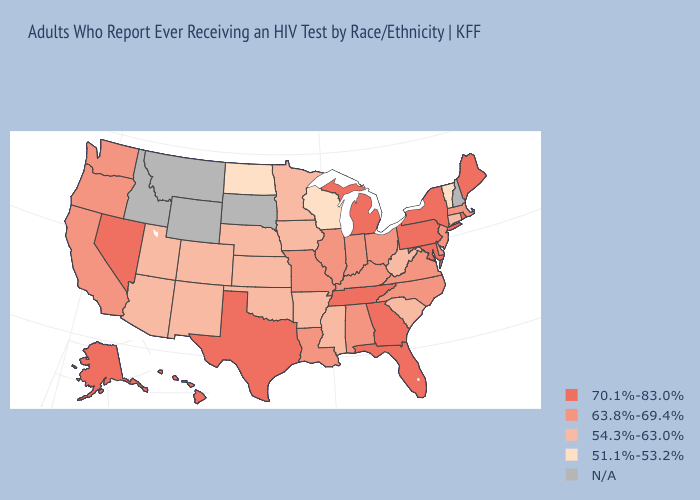Does Florida have the highest value in the South?
Give a very brief answer. Yes. Name the states that have a value in the range N/A?
Answer briefly. Idaho, Montana, New Hampshire, South Dakota, Wyoming. Name the states that have a value in the range 54.3%-63.0%?
Quick response, please. Arizona, Arkansas, Colorado, Connecticut, Iowa, Kansas, Minnesota, Mississippi, Nebraska, New Mexico, Oklahoma, South Carolina, Utah, West Virginia. Among the states that border New York , which have the lowest value?
Short answer required. Vermont. Among the states that border Vermont , which have the highest value?
Write a very short answer. New York. Name the states that have a value in the range 70.1%-83.0%?
Concise answer only. Alaska, Florida, Georgia, Hawaii, Maine, Maryland, Michigan, Nevada, New York, Pennsylvania, Rhode Island, Tennessee, Texas. What is the value of Hawaii?
Be succinct. 70.1%-83.0%. Does Hawaii have the highest value in the West?
Short answer required. Yes. Name the states that have a value in the range 70.1%-83.0%?
Short answer required. Alaska, Florida, Georgia, Hawaii, Maine, Maryland, Michigan, Nevada, New York, Pennsylvania, Rhode Island, Tennessee, Texas. Among the states that border Mississippi , which have the highest value?
Concise answer only. Tennessee. Name the states that have a value in the range N/A?
Give a very brief answer. Idaho, Montana, New Hampshire, South Dakota, Wyoming. 